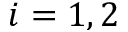Convert formula to latex. <formula><loc_0><loc_0><loc_500><loc_500>i = 1 , 2</formula> 